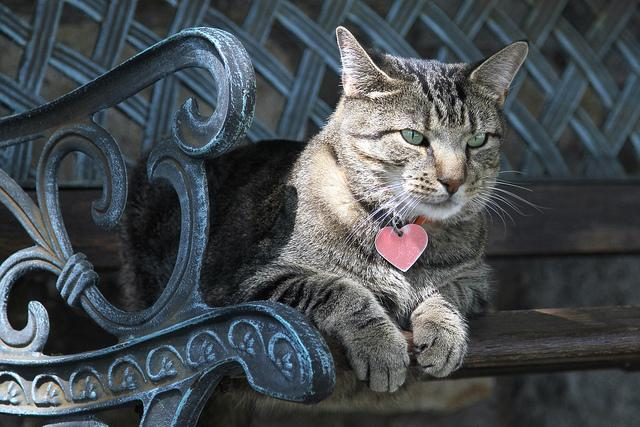What is the purpose of the heart around the cats neck? tag 